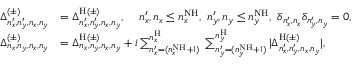Convert formula to latex. <formula><loc_0><loc_0><loc_500><loc_500>\begin{array} { r l } { \Delta _ { n _ { x } ^ { \prime } , n _ { y } ^ { \prime } , n _ { x } , n _ { y } } ^ { ( \pm ) } } & { = \Delta _ { n _ { x } ^ { \prime } , n _ { y } ^ { \prime } , n _ { x } , n _ { y } } ^ { H ( \pm ) } , \, n _ { x } ^ { \prime } , n _ { x } \leq n _ { x } ^ { N H } , \, n _ { y } ^ { \prime } , n _ { y } \leq n _ { y } ^ { N H } , \, \delta _ { n _ { x } ^ { \prime } , n _ { x } } \delta _ { n _ { y } ^ { \prime } , n _ { y } } = 0 , } \\ { \Delta _ { n _ { x } , n _ { y } , n _ { x } , n _ { y } } ^ { ( \pm ) } } & { = \Delta _ { n _ { x } , n _ { y } , n _ { x } , n _ { y } } ^ { H ( \pm ) } + i \sum _ { n _ { x } ^ { \prime } = ( n _ { x } ^ { N H } + 1 ) } ^ { n _ { x } ^ { H } } \, \sum _ { n _ { y } ^ { \prime } = ( n _ { y } ^ { N H } + 1 ) } ^ { n _ { y } ^ { H } } | \Delta _ { n _ { x } ^ { \prime } , n _ { y } ^ { \prime } , n _ { x } , n _ { y } } ^ { H ( \pm ) } | , } \end{array}</formula> 